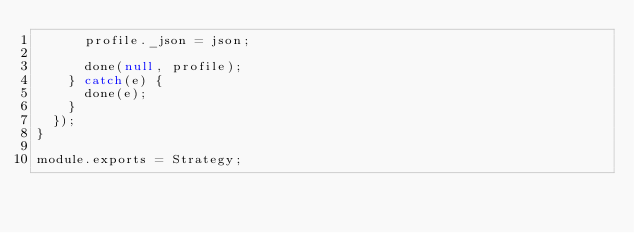<code> <loc_0><loc_0><loc_500><loc_500><_JavaScript_>      profile._json = json;

      done(null, profile);
    } catch(e) {
      done(e);
    }
  });
}

module.exports = Strategy;
</code> 